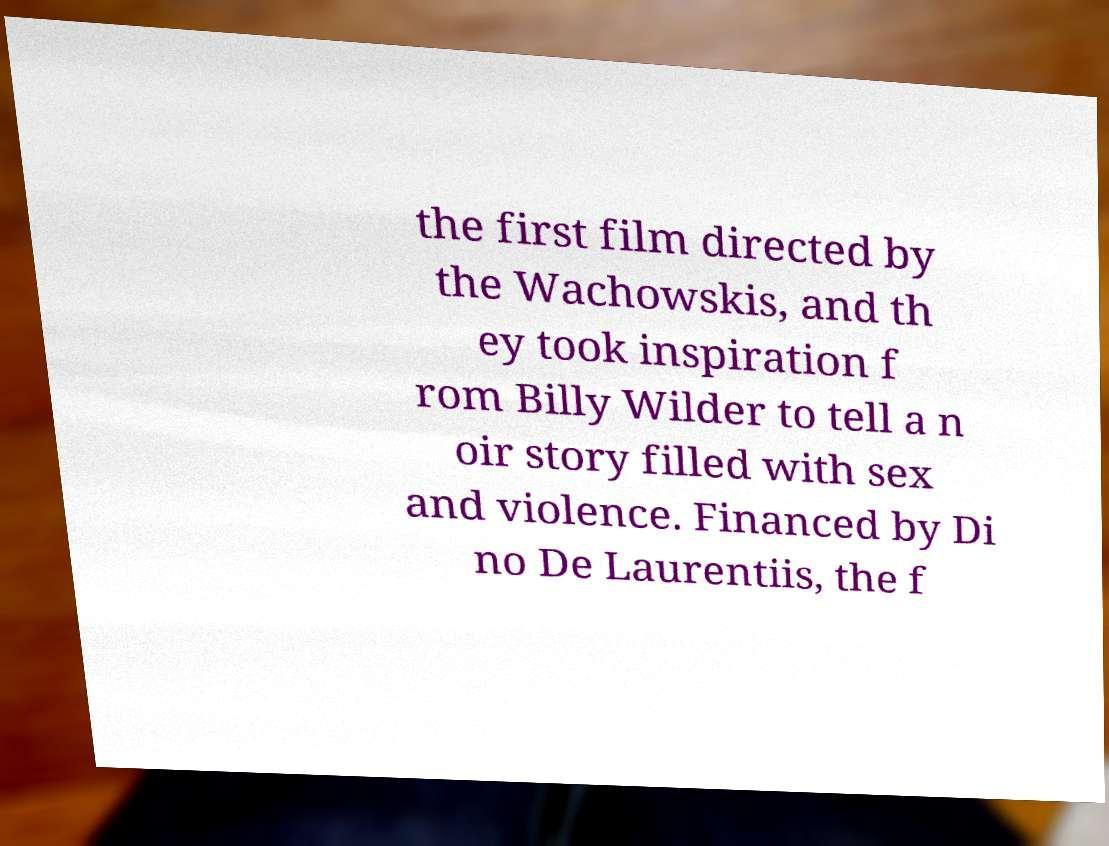I need the written content from this picture converted into text. Can you do that? the first film directed by the Wachowskis, and th ey took inspiration f rom Billy Wilder to tell a n oir story filled with sex and violence. Financed by Di no De Laurentiis, the f 